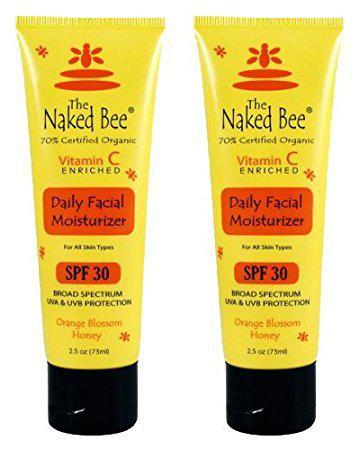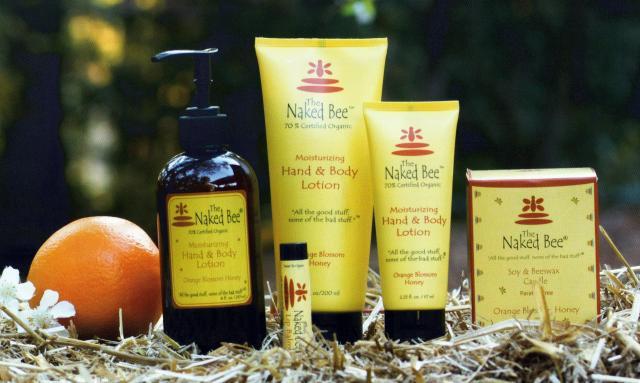The first image is the image on the left, the second image is the image on the right. For the images shown, is this caption "Each image includes yellow tubes that stand on flat black flip-top caps, but only the right image includes a dark brown bottle with a black pump top." true? Answer yes or no. Yes. 